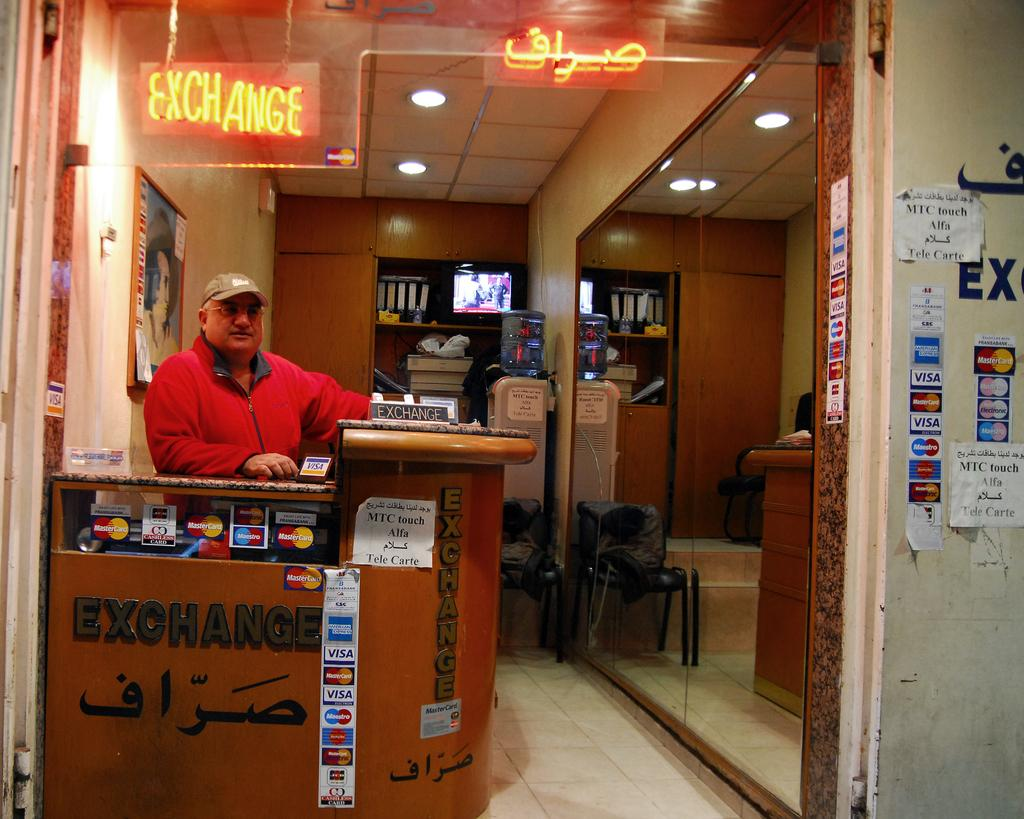What is the color of the wall in the image? The wall in the image is white. What is hanging on the wall in the image? There is a frame and a poster hanging on the wall in the image. Who is present in the image? There is a man in the image. What is located on the right side of the image? There is a mirror and a chair on the right side of the image. Can you tell me how many feathers are on the vase in the image? There is no vase or feathers present in the image. What is the man's current state of health in the image? The image does not provide any information about the man's health, so it cannot be determined. 